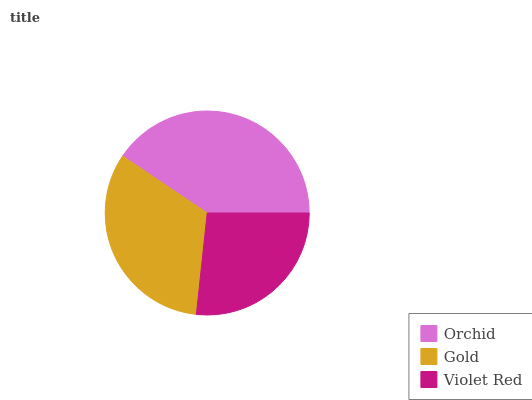Is Violet Red the minimum?
Answer yes or no. Yes. Is Orchid the maximum?
Answer yes or no. Yes. Is Gold the minimum?
Answer yes or no. No. Is Gold the maximum?
Answer yes or no. No. Is Orchid greater than Gold?
Answer yes or no. Yes. Is Gold less than Orchid?
Answer yes or no. Yes. Is Gold greater than Orchid?
Answer yes or no. No. Is Orchid less than Gold?
Answer yes or no. No. Is Gold the high median?
Answer yes or no. Yes. Is Gold the low median?
Answer yes or no. Yes. Is Violet Red the high median?
Answer yes or no. No. Is Orchid the low median?
Answer yes or no. No. 